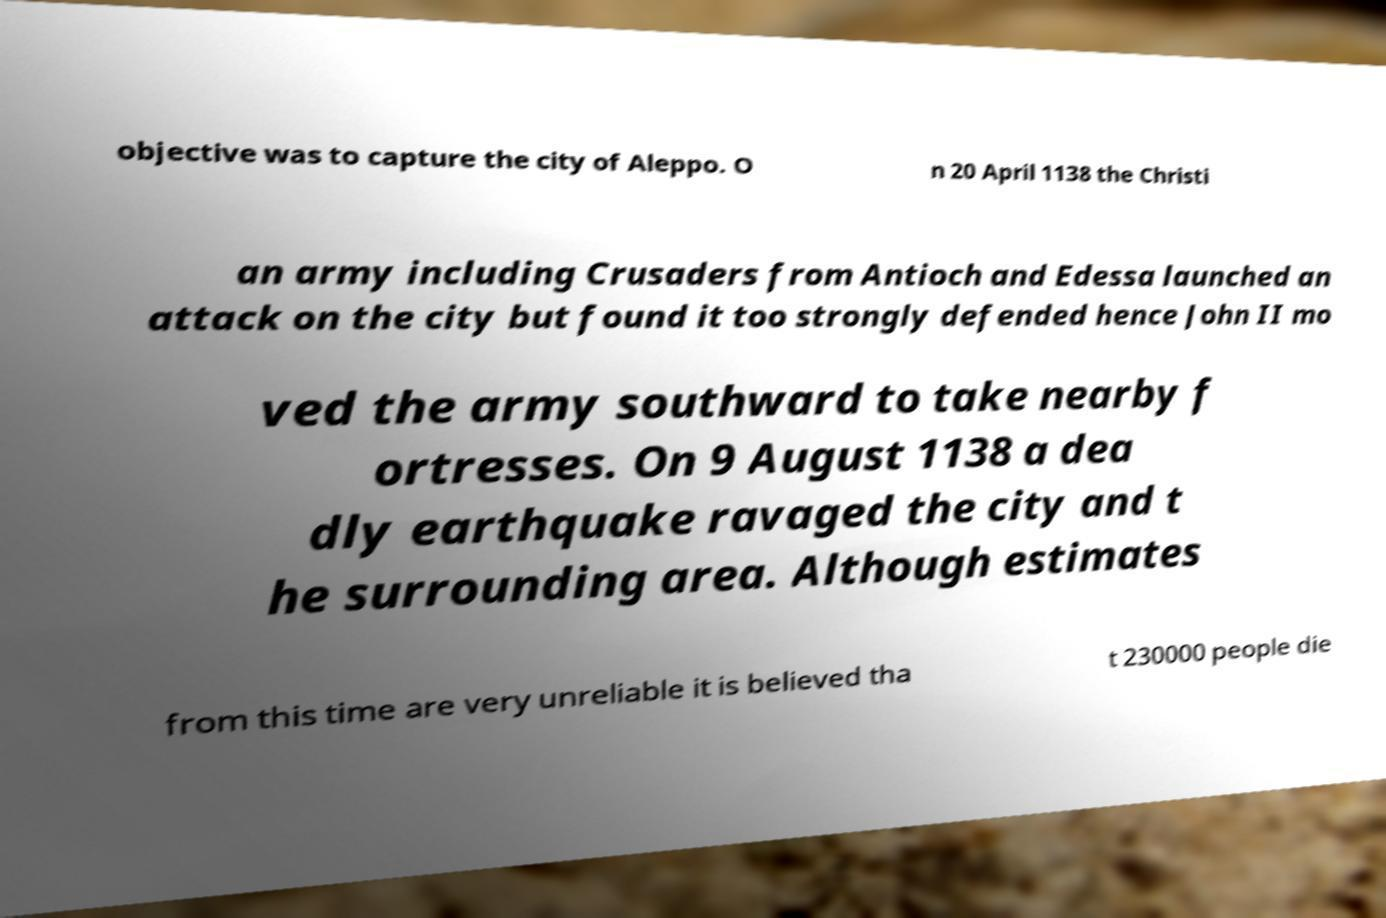Could you assist in decoding the text presented in this image and type it out clearly? objective was to capture the city of Aleppo. O n 20 April 1138 the Christi an army including Crusaders from Antioch and Edessa launched an attack on the city but found it too strongly defended hence John II mo ved the army southward to take nearby f ortresses. On 9 August 1138 a dea dly earthquake ravaged the city and t he surrounding area. Although estimates from this time are very unreliable it is believed tha t 230000 people die 